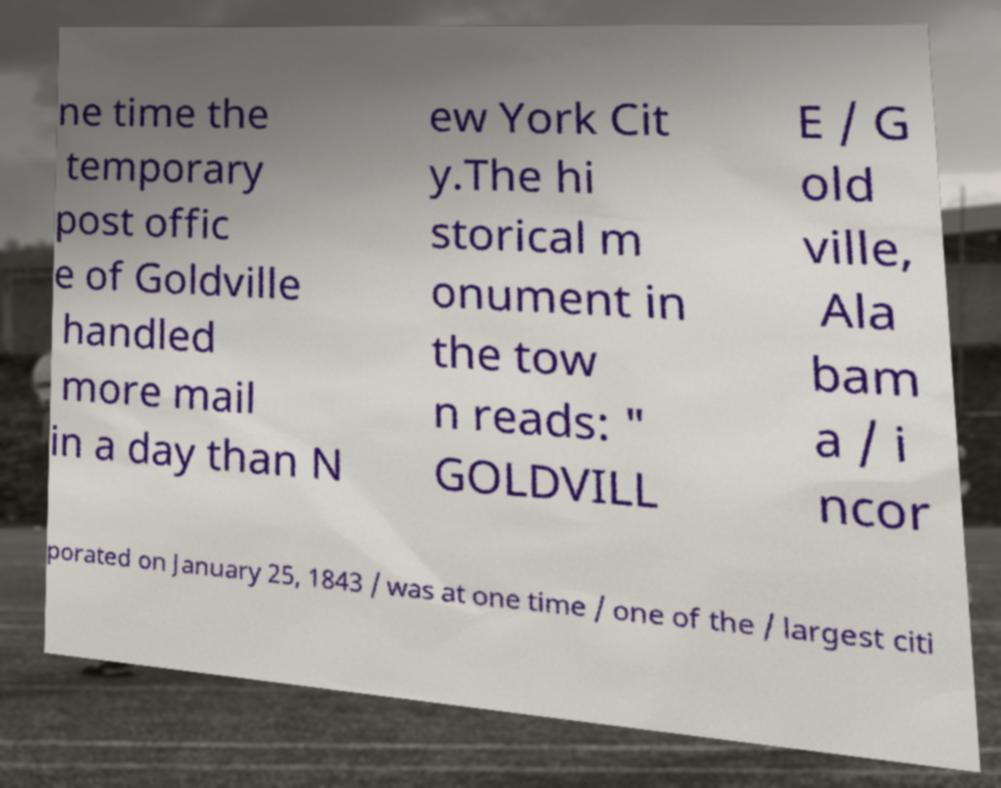I need the written content from this picture converted into text. Can you do that? ne time the temporary post offic e of Goldville handled more mail in a day than N ew York Cit y.The hi storical m onument in the tow n reads: " GOLDVILL E / G old ville, Ala bam a / i ncor porated on January 25, 1843 / was at one time / one of the / largest citi 